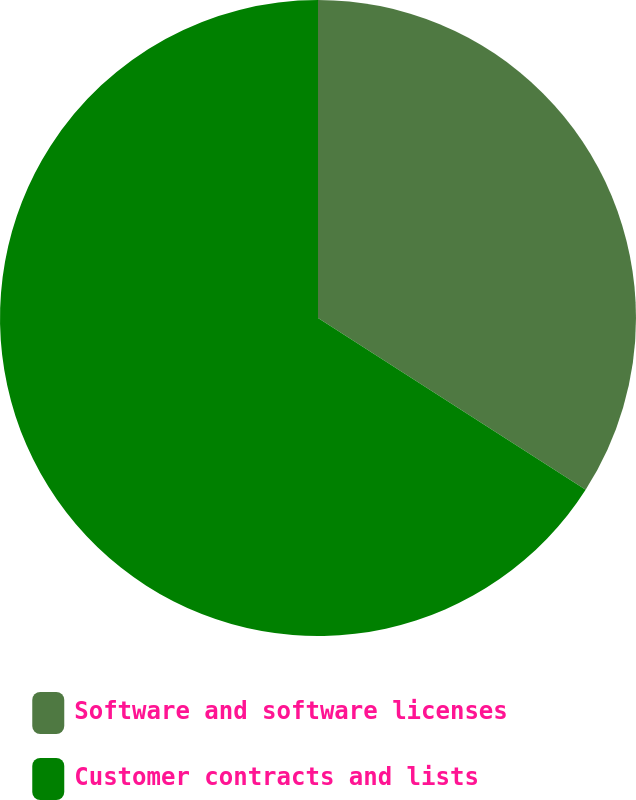<chart> <loc_0><loc_0><loc_500><loc_500><pie_chart><fcel>Software and software licenses<fcel>Customer contracts and lists<nl><fcel>34.08%<fcel>65.92%<nl></chart> 